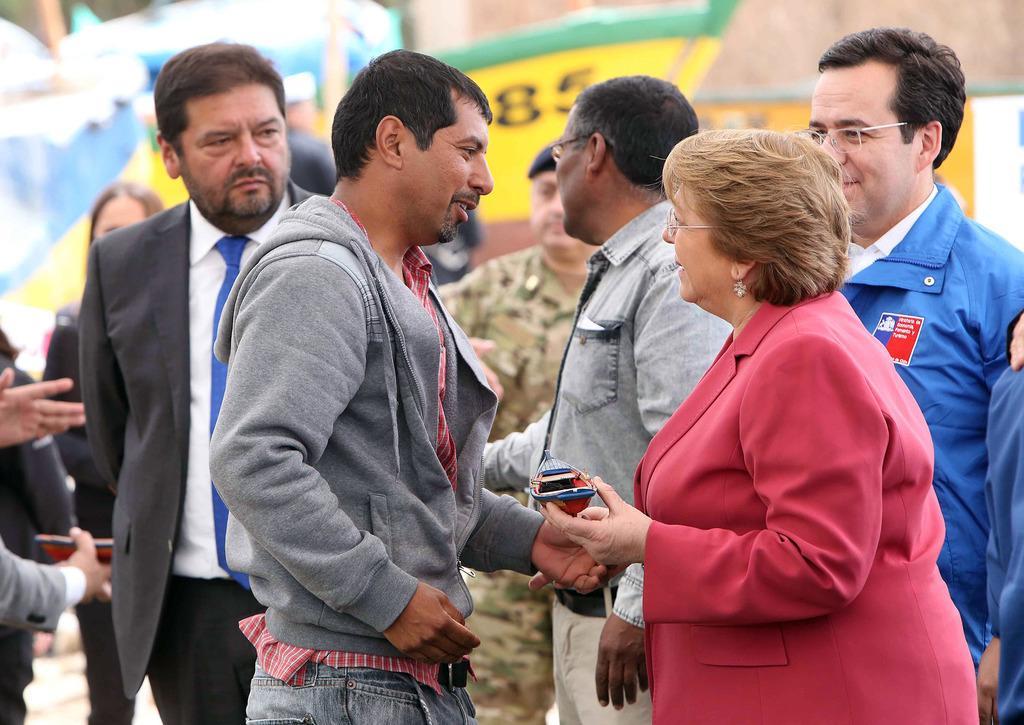Please provide a concise description of this image. In this image we can see a group of people standing on the ground. One woman wearing spectacles and red coat is holding a toy in her hand. In the background, we can see group of boats. 